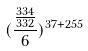<formula> <loc_0><loc_0><loc_500><loc_500>( \frac { \frac { 3 3 4 } { 3 3 2 } } { 6 } ) ^ { 3 7 + 2 5 5 }</formula> 